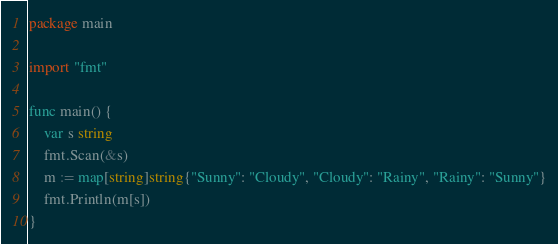Convert code to text. <code><loc_0><loc_0><loc_500><loc_500><_Go_>package main

import "fmt"

func main() {
	var s string
	fmt.Scan(&s)
	m := map[string]string{"Sunny": "Cloudy", "Cloudy": "Rainy", "Rainy": "Sunny"}
	fmt.Println(m[s])
}
</code> 